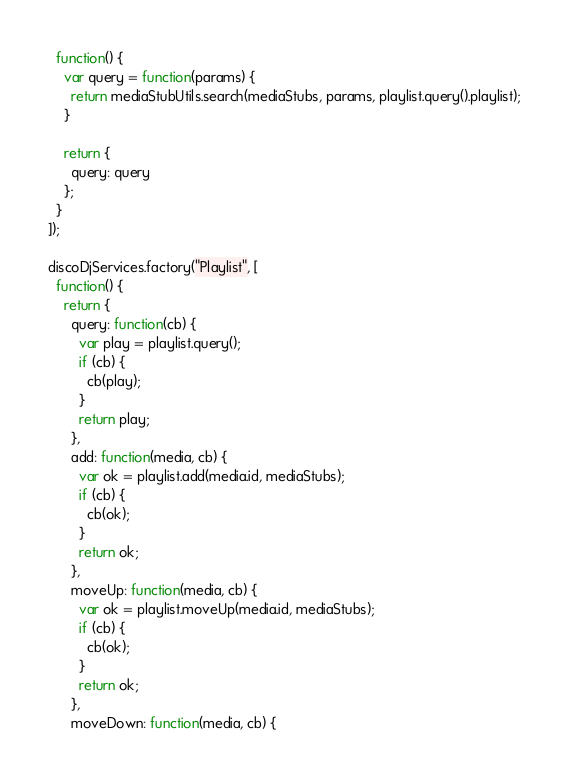Convert code to text. <code><loc_0><loc_0><loc_500><loc_500><_JavaScript_>  function() {
    var query = function(params) {
      return mediaStubUtils.search(mediaStubs, params, playlist.query().playlist);
    }

    return {
      query: query
    };
  }
]);

discoDjServices.factory("Playlist", [
  function() {
    return {
      query: function(cb) {
        var play = playlist.query();
        if (cb) {
          cb(play);
        }
        return play;
      },
      add: function(media, cb) {
        var ok = playlist.add(media.id, mediaStubs);
        if (cb) {
          cb(ok);
        }
        return ok;
      },
      moveUp: function(media, cb) {
        var ok = playlist.moveUp(media.id, mediaStubs);
        if (cb) {
          cb(ok);
        }
        return ok;
      },
      moveDown: function(media, cb) {</code> 